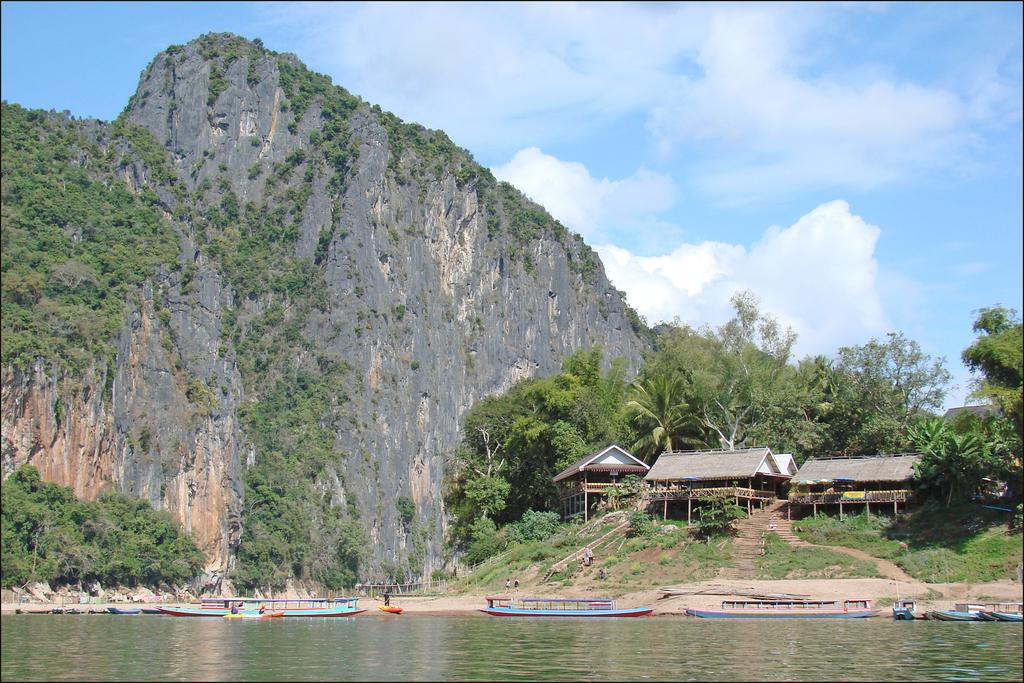What type of location is depicted in the image? There is a beach in the image. What can be seen on the beach besides the sand? There are boats and huts on the beach. What is the geographical feature visible in the background of the image? There is a hill in the image. What kind of vegetation is present on the hill? The hill has trees and plants on it. What type of structure is being celebrated on the beach in the image? There is no indication of a celebration or structure being celebrated in the image. 